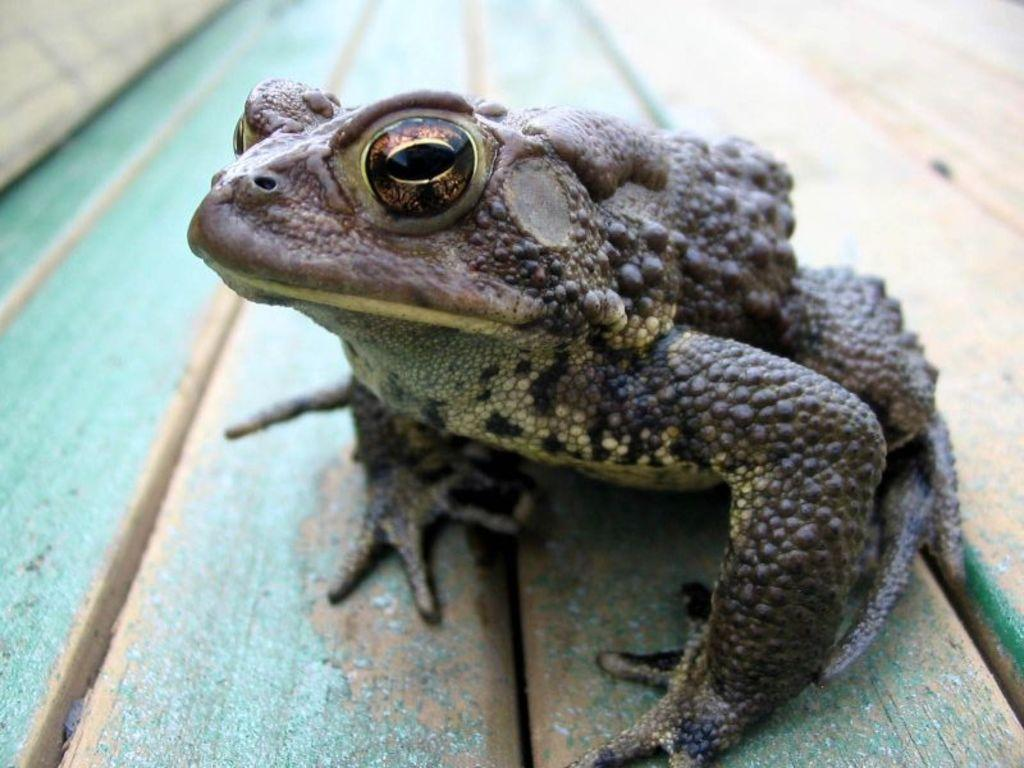What is the dominant color of the surface in the image? The surface in the image has a green color. What type of animal can be seen on the green surface? There is a frog on the green surface. What type of leaf is being used as a club by the grandmother in the image? There is no leaf, club, or grandmother present in the image; it only features a green surface with a frog on it. 